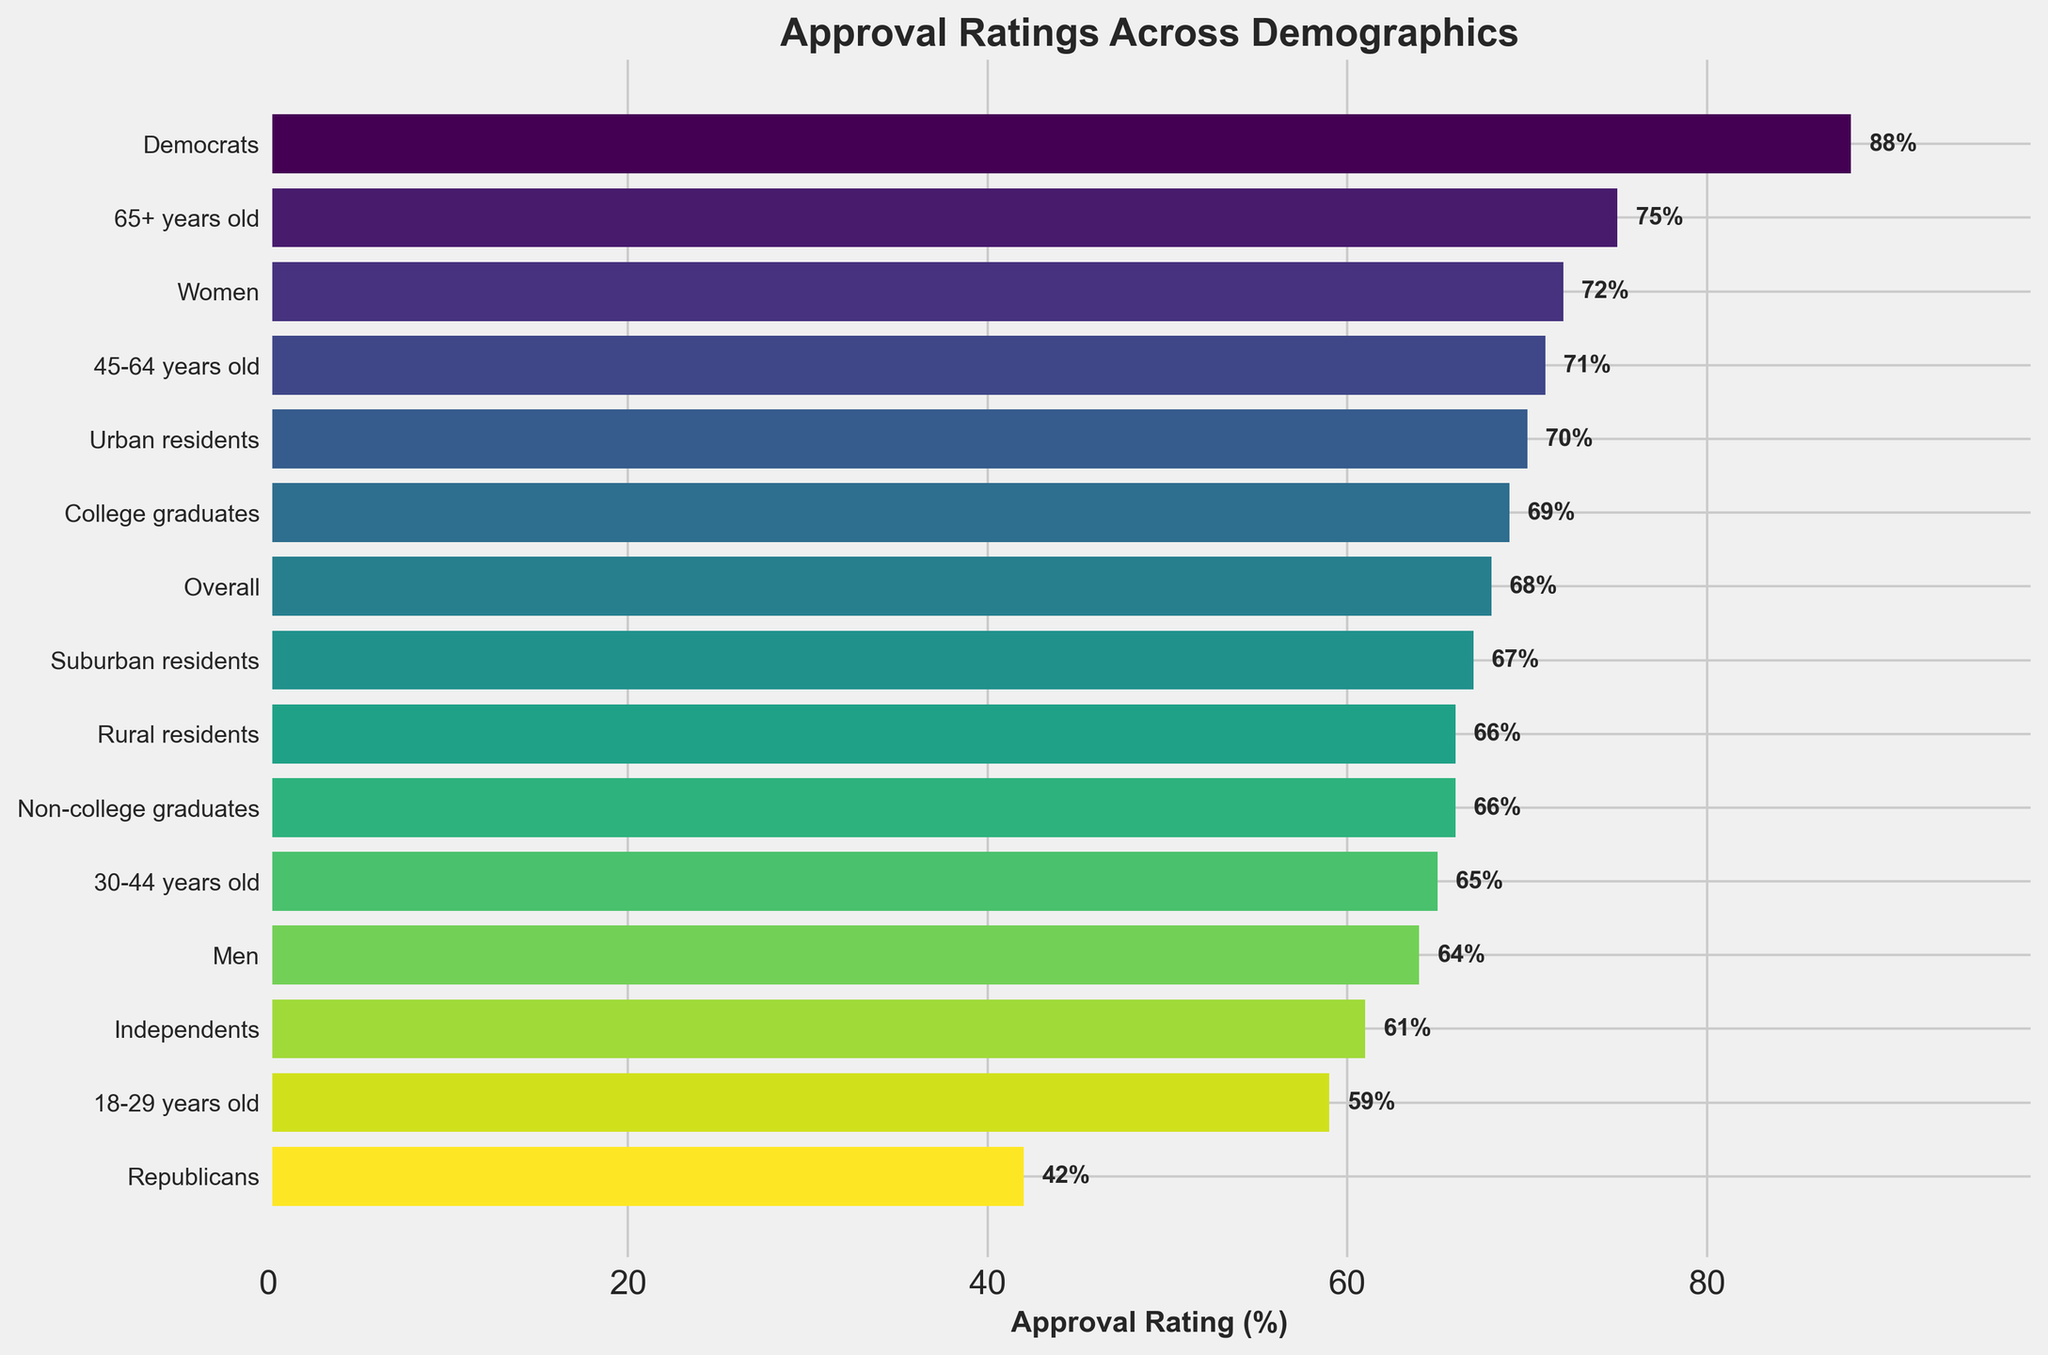Which demographic group has the highest approval rating? Looking at the funnel chart, identify which bar reaches farthest to the right. The 65+ years old group has the highest approval rating at 75%.
Answer: 65+ years old What is the difference in approval ratings between Women and Men? Find the approval ratings for Women (72%) and Men (64%) in the chart, then subtract the latter from the former: 72 - 64 = 8.
Answer: 8 How does the approval rating of Democrats compare to Republicans? Look at the approval ratings for Democrats (88%) and Republicans (42%) and compare them. Democrats have a significantly higher approval rating than Republicans.
Answer: Democrats have a significantly higher approval rating What is the average approval rating for the age-specific demographic groups? Add the approval ratings of the 18-29 years old (59%), 30-44 years old (65%), 45-64 years old (71%), and 65+ years old (75%) demographics, then divide by 4. (59 + 65 + 71 + 75) / 4 = 67.5
Answer: 67.5 Which group has a higher approval rating: Urban residents or Rural residents? Compare the approval ratings for Urban residents (70%) and Rural residents (66%) from the chart. Urban residents have a higher approval rating.
Answer: Urban residents What is the combined approval rating of Independents and Republicans? Add the approval ratings of Independents (61%) and Republicans (42%): 61 + 42 = 103.
Answer: 103 By how much does the overall approval rating exceed the approval rating of Independents? Subtract Independents' approval rating (61%) from the overall approval rating (68%): 68 - 61 = 7.
Answer: 7 Which demographic segment has the lowest approval rating? Identify the shortest bar in the funnel chart, which represents Republicans with a 42% approval rating.
Answer: Republicans How do the approval ratings for college graduates and non-college graduates compare? Check the approval ratings for college graduates (69%) and non-college graduates (66%), then compare them. College graduates have a slightly higher approval rating.
Answer: College graduates have a slightly higher approval rating What is the total number of demographic groups displayed in the funnel chart? Count the number of bars (demographic groups) in the chart. There are 15 groups displayed.
Answer: 15 